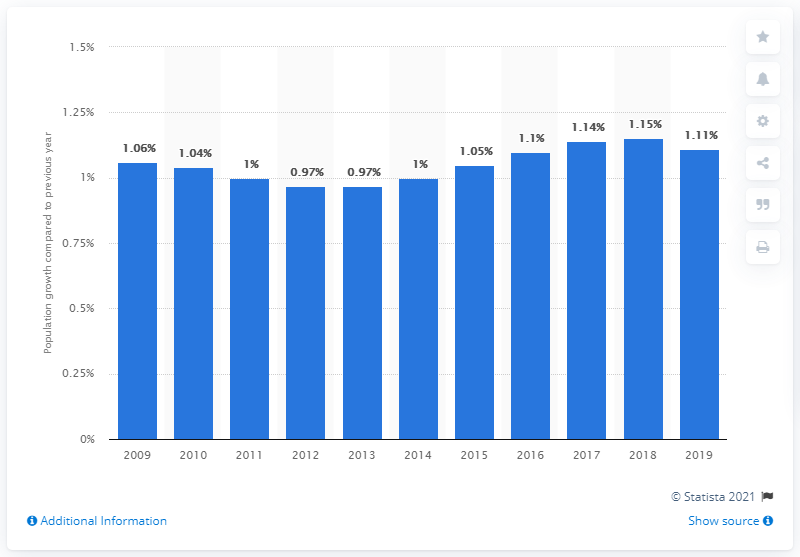List a handful of essential elements in this visual. In 2019, the population of Tunisia increased by 1.11%. 